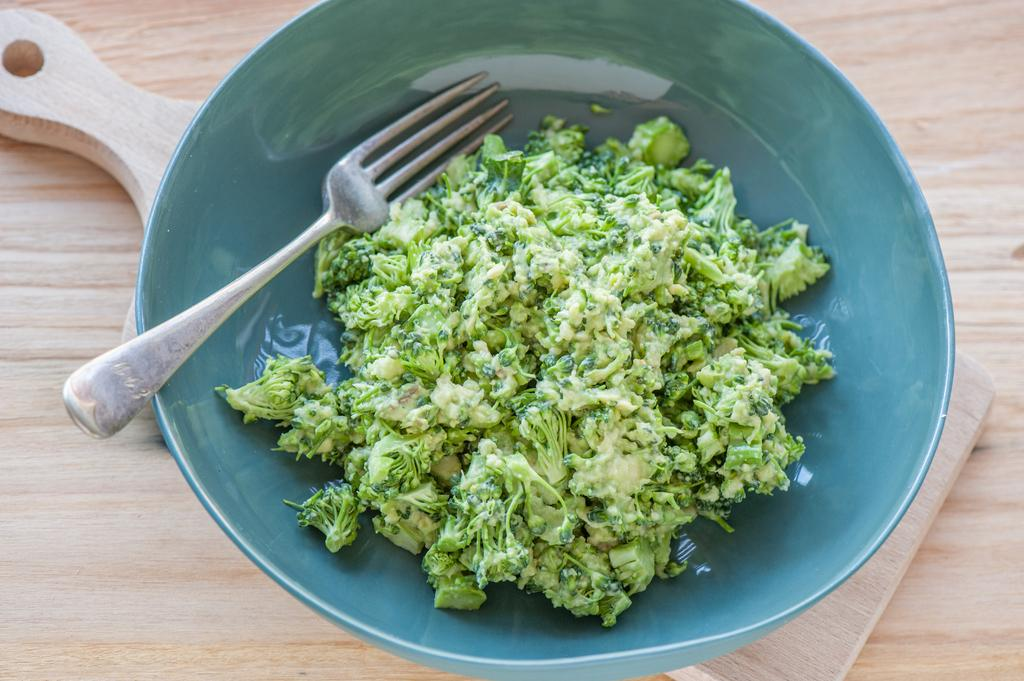What is in the bowl that is visible in the image? There is food in the bowl. What can be said about the color of the food in the bowl? The food is green in color. What utensil is visible in the image? There is a fork visible in the image. What type of surface is the bowl placed on? The bowl is on a wooden surface. What is the purpose of the wall in the image? There is no wall present in the image. 